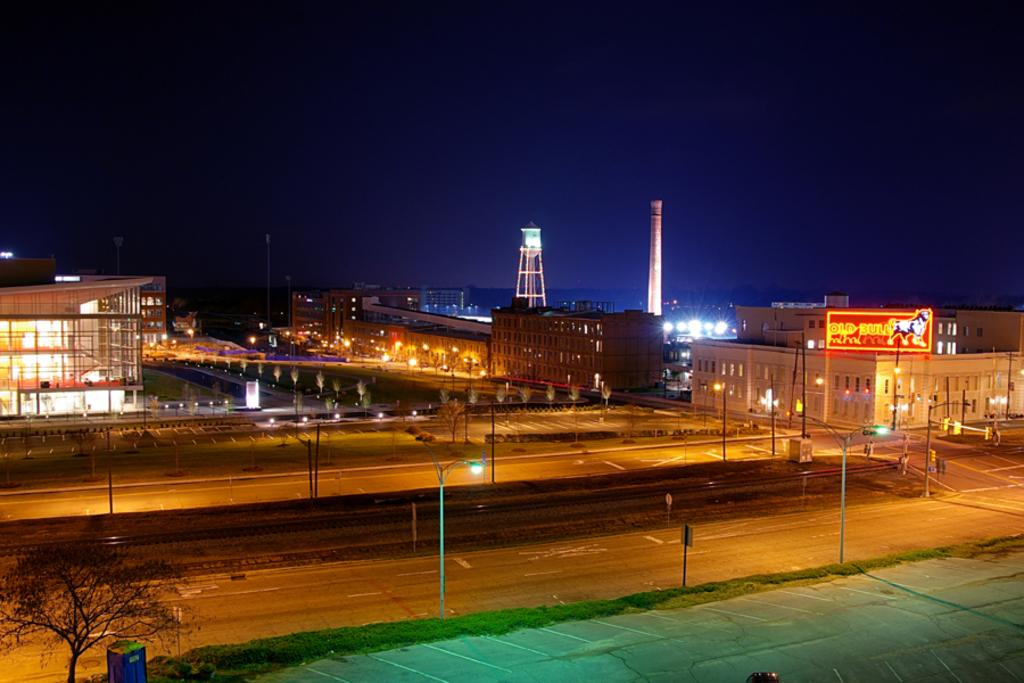What type of vegetation can be seen in the image? There is a tree in the image. What objects are present on the ground in the image? There are boards in the image. What type of lighting is present in the image? There are lights on poles in the image. What type of man-made structure is visible in the image? There is a road in the image. What can be seen in the background of the image? There are buildings, trees, a tower, and the sky visible in the background of the image. What type of advertisement is present in the background of the image? There is a hoarding on a building in the background of the image. Can you tell me how many people are attending the party in the image? There is no party present in the image. What type of hot beverage is being served in the image? There is no hot beverage present in the image. 